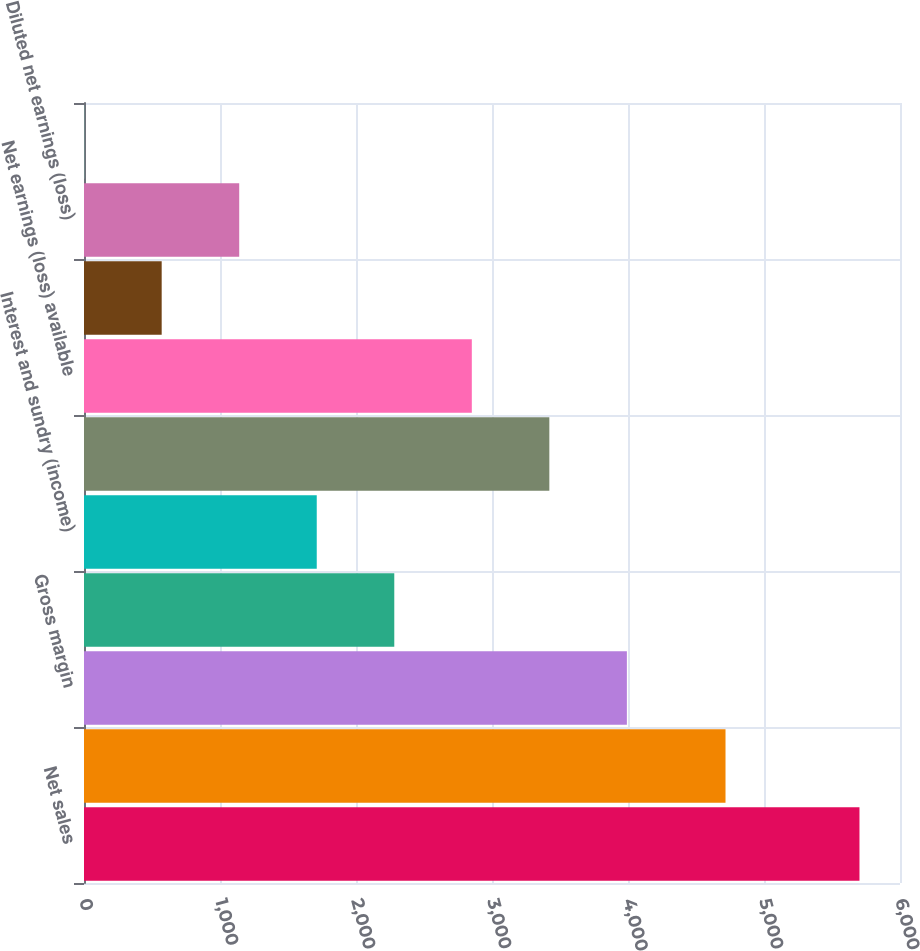Convert chart to OTSL. <chart><loc_0><loc_0><loc_500><loc_500><bar_chart><fcel>Net sales<fcel>Cost of products sold<fcel>Gross margin<fcel>Operating profit (loss)<fcel>Interest and sundry (income)<fcel>Net earnings (loss)<fcel>Net earnings (loss) available<fcel>Basic net earnings (loss)<fcel>Diluted net earnings (loss)<fcel>Dividends<nl><fcel>5702<fcel>4717<fcel>3991.73<fcel>2281.46<fcel>1711.37<fcel>3421.64<fcel>2851.55<fcel>571.19<fcel>1141.28<fcel>1.1<nl></chart> 